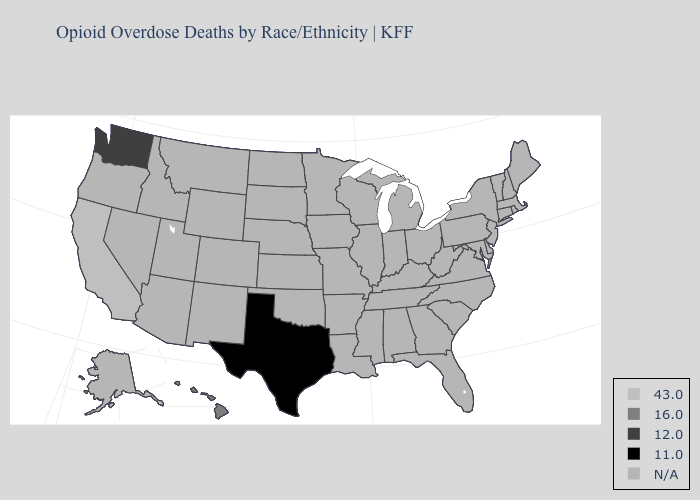What is the value of Massachusetts?
Give a very brief answer. N/A. What is the value of New York?
Write a very short answer. N/A. Does Texas have the highest value in the USA?
Give a very brief answer. No. What is the value of Idaho?
Concise answer only. N/A. What is the lowest value in the USA?
Short answer required. 11.0. What is the value of Nevada?
Answer briefly. N/A. Among the states that border New Mexico , which have the lowest value?
Give a very brief answer. Texas. Name the states that have a value in the range 11.0?
Answer briefly. Texas. What is the lowest value in the USA?
Give a very brief answer. 11.0. What is the value of Ohio?
Keep it brief. N/A. What is the value of Maryland?
Short answer required. N/A. Name the states that have a value in the range N/A?
Concise answer only. Alabama, Alaska, Arizona, Arkansas, Colorado, Connecticut, Delaware, Florida, Georgia, Idaho, Illinois, Indiana, Iowa, Kansas, Kentucky, Louisiana, Maine, Maryland, Massachusetts, Michigan, Minnesota, Mississippi, Missouri, Montana, Nebraska, Nevada, New Hampshire, New Jersey, New Mexico, New York, North Carolina, North Dakota, Ohio, Oklahoma, Oregon, Pennsylvania, Rhode Island, South Carolina, South Dakota, Tennessee, Utah, Vermont, Virginia, West Virginia, Wisconsin, Wyoming. What is the highest value in the West ?
Concise answer only. 43.0. 